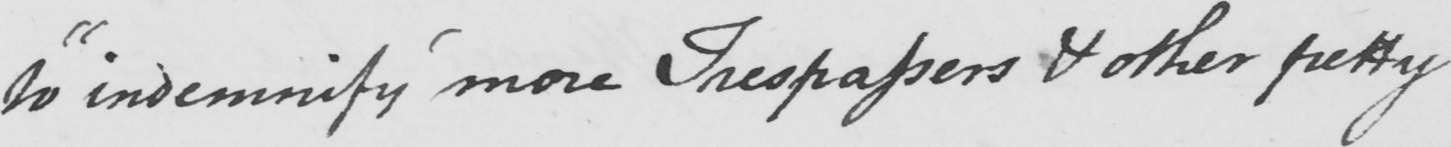Please transcribe the handwritten text in this image. to  " indemnify more Trespassers & other petty 